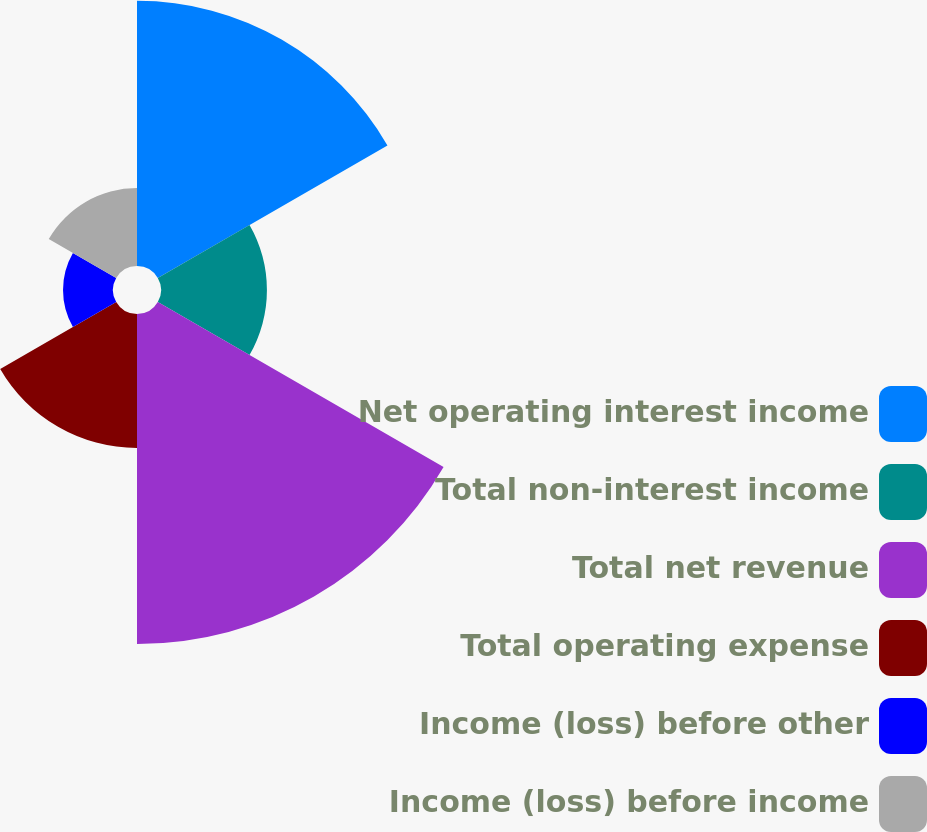Convert chart. <chart><loc_0><loc_0><loc_500><loc_500><pie_chart><fcel>Net operating interest income<fcel>Total non-interest income<fcel>Total net revenue<fcel>Total operating expense<fcel>Income (loss) before other<fcel>Income (loss) before income<nl><fcel>27.54%<fcel>11.0%<fcel>34.27%<fcel>13.91%<fcel>5.19%<fcel>8.09%<nl></chart> 